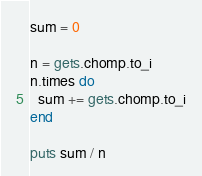<code> <loc_0><loc_0><loc_500><loc_500><_Ruby_>sum = 0

n = gets.chomp.to_i
n.times do
  sum += gets.chomp.to_i
end

puts sum / n</code> 